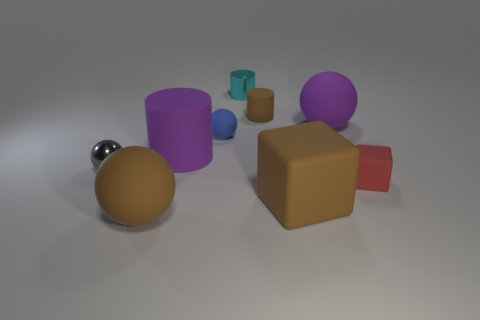How many objects in total can be counted within this image? There are eight distinct objects visible in this image, varying in shape, size, and color. 